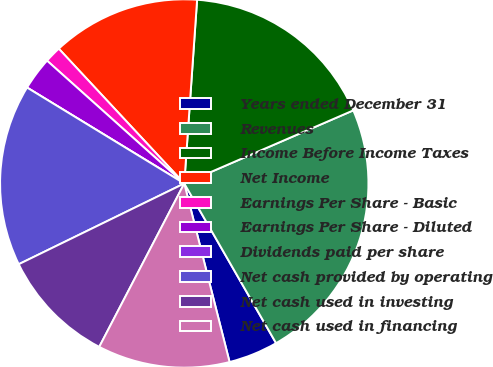Convert chart. <chart><loc_0><loc_0><loc_500><loc_500><pie_chart><fcel>Years ended December 31<fcel>Revenues<fcel>Income Before Income Taxes<fcel>Net Income<fcel>Earnings Per Share - Basic<fcel>Earnings Per Share - Diluted<fcel>Dividends paid per share<fcel>Net cash provided by operating<fcel>Net cash used in investing<fcel>Net cash used in financing<nl><fcel>4.35%<fcel>23.19%<fcel>17.39%<fcel>13.04%<fcel>1.45%<fcel>2.9%<fcel>0.0%<fcel>15.94%<fcel>10.14%<fcel>11.59%<nl></chart> 